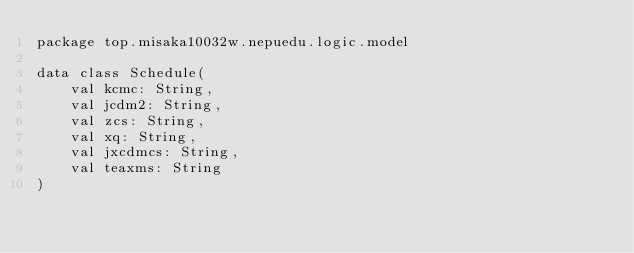<code> <loc_0><loc_0><loc_500><loc_500><_Kotlin_>package top.misaka10032w.nepuedu.logic.model

data class Schedule(
    val kcmc: String,
    val jcdm2: String,
    val zcs: String,
    val xq: String,
    val jxcdmcs: String,
    val teaxms: String
)</code> 